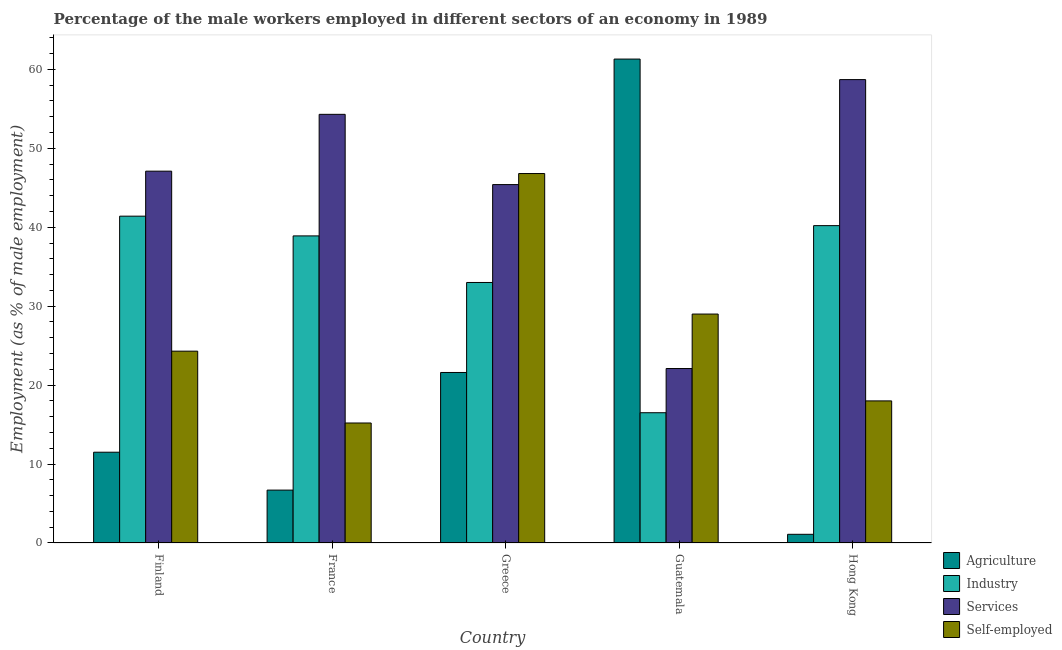How many different coloured bars are there?
Offer a terse response. 4. Are the number of bars per tick equal to the number of legend labels?
Provide a short and direct response. Yes. Are the number of bars on each tick of the X-axis equal?
Provide a short and direct response. Yes. How many bars are there on the 2nd tick from the left?
Give a very brief answer. 4. What is the label of the 4th group of bars from the left?
Give a very brief answer. Guatemala. What is the percentage of self employed male workers in Finland?
Keep it short and to the point. 24.3. Across all countries, what is the maximum percentage of male workers in industry?
Provide a short and direct response. 41.4. Across all countries, what is the minimum percentage of self employed male workers?
Make the answer very short. 15.2. In which country was the percentage of self employed male workers maximum?
Ensure brevity in your answer.  Greece. In which country was the percentage of male workers in agriculture minimum?
Give a very brief answer. Hong Kong. What is the total percentage of male workers in agriculture in the graph?
Make the answer very short. 102.2. What is the difference between the percentage of male workers in services in Greece and that in Hong Kong?
Your answer should be compact. -13.3. What is the difference between the percentage of male workers in services in Greece and the percentage of self employed male workers in France?
Make the answer very short. 30.2. What is the average percentage of self employed male workers per country?
Your answer should be very brief. 26.66. What is the difference between the percentage of male workers in agriculture and percentage of male workers in industry in Greece?
Offer a very short reply. -11.4. What is the ratio of the percentage of male workers in industry in Finland to that in Guatemala?
Ensure brevity in your answer.  2.51. Is the percentage of male workers in industry in Finland less than that in Greece?
Make the answer very short. No. What is the difference between the highest and the second highest percentage of self employed male workers?
Offer a very short reply. 17.8. What is the difference between the highest and the lowest percentage of self employed male workers?
Offer a very short reply. 31.6. What does the 1st bar from the left in Greece represents?
Ensure brevity in your answer.  Agriculture. What does the 4th bar from the right in Hong Kong represents?
Make the answer very short. Agriculture. How many countries are there in the graph?
Your response must be concise. 5. What is the difference between two consecutive major ticks on the Y-axis?
Your answer should be compact. 10. Are the values on the major ticks of Y-axis written in scientific E-notation?
Your answer should be very brief. No. Does the graph contain any zero values?
Offer a terse response. No. What is the title of the graph?
Your response must be concise. Percentage of the male workers employed in different sectors of an economy in 1989. Does "Argument" appear as one of the legend labels in the graph?
Your response must be concise. No. What is the label or title of the Y-axis?
Make the answer very short. Employment (as % of male employment). What is the Employment (as % of male employment) of Industry in Finland?
Ensure brevity in your answer.  41.4. What is the Employment (as % of male employment) of Services in Finland?
Provide a short and direct response. 47.1. What is the Employment (as % of male employment) of Self-employed in Finland?
Your response must be concise. 24.3. What is the Employment (as % of male employment) in Agriculture in France?
Offer a terse response. 6.7. What is the Employment (as % of male employment) of Industry in France?
Give a very brief answer. 38.9. What is the Employment (as % of male employment) in Services in France?
Offer a very short reply. 54.3. What is the Employment (as % of male employment) in Self-employed in France?
Ensure brevity in your answer.  15.2. What is the Employment (as % of male employment) of Agriculture in Greece?
Your answer should be very brief. 21.6. What is the Employment (as % of male employment) in Services in Greece?
Provide a succinct answer. 45.4. What is the Employment (as % of male employment) of Self-employed in Greece?
Give a very brief answer. 46.8. What is the Employment (as % of male employment) in Agriculture in Guatemala?
Offer a very short reply. 61.3. What is the Employment (as % of male employment) of Industry in Guatemala?
Offer a terse response. 16.5. What is the Employment (as % of male employment) of Services in Guatemala?
Give a very brief answer. 22.1. What is the Employment (as % of male employment) of Self-employed in Guatemala?
Provide a short and direct response. 29. What is the Employment (as % of male employment) in Agriculture in Hong Kong?
Your answer should be compact. 1.1. What is the Employment (as % of male employment) in Industry in Hong Kong?
Your answer should be compact. 40.2. What is the Employment (as % of male employment) in Services in Hong Kong?
Provide a succinct answer. 58.7. What is the Employment (as % of male employment) of Self-employed in Hong Kong?
Offer a terse response. 18. Across all countries, what is the maximum Employment (as % of male employment) in Agriculture?
Ensure brevity in your answer.  61.3. Across all countries, what is the maximum Employment (as % of male employment) of Industry?
Your answer should be compact. 41.4. Across all countries, what is the maximum Employment (as % of male employment) in Services?
Provide a short and direct response. 58.7. Across all countries, what is the maximum Employment (as % of male employment) of Self-employed?
Offer a terse response. 46.8. Across all countries, what is the minimum Employment (as % of male employment) in Agriculture?
Give a very brief answer. 1.1. Across all countries, what is the minimum Employment (as % of male employment) in Industry?
Your answer should be compact. 16.5. Across all countries, what is the minimum Employment (as % of male employment) in Services?
Give a very brief answer. 22.1. Across all countries, what is the minimum Employment (as % of male employment) in Self-employed?
Your answer should be compact. 15.2. What is the total Employment (as % of male employment) in Agriculture in the graph?
Your answer should be very brief. 102.2. What is the total Employment (as % of male employment) in Industry in the graph?
Make the answer very short. 170. What is the total Employment (as % of male employment) of Services in the graph?
Offer a very short reply. 227.6. What is the total Employment (as % of male employment) of Self-employed in the graph?
Keep it short and to the point. 133.3. What is the difference between the Employment (as % of male employment) of Industry in Finland and that in Greece?
Ensure brevity in your answer.  8.4. What is the difference between the Employment (as % of male employment) in Self-employed in Finland and that in Greece?
Provide a short and direct response. -22.5. What is the difference between the Employment (as % of male employment) in Agriculture in Finland and that in Guatemala?
Provide a succinct answer. -49.8. What is the difference between the Employment (as % of male employment) in Industry in Finland and that in Guatemala?
Make the answer very short. 24.9. What is the difference between the Employment (as % of male employment) of Self-employed in Finland and that in Guatemala?
Your answer should be compact. -4.7. What is the difference between the Employment (as % of male employment) in Agriculture in Finland and that in Hong Kong?
Provide a short and direct response. 10.4. What is the difference between the Employment (as % of male employment) of Self-employed in Finland and that in Hong Kong?
Your response must be concise. 6.3. What is the difference between the Employment (as % of male employment) in Agriculture in France and that in Greece?
Your answer should be very brief. -14.9. What is the difference between the Employment (as % of male employment) of Industry in France and that in Greece?
Your answer should be very brief. 5.9. What is the difference between the Employment (as % of male employment) in Self-employed in France and that in Greece?
Offer a terse response. -31.6. What is the difference between the Employment (as % of male employment) of Agriculture in France and that in Guatemala?
Ensure brevity in your answer.  -54.6. What is the difference between the Employment (as % of male employment) in Industry in France and that in Guatemala?
Provide a succinct answer. 22.4. What is the difference between the Employment (as % of male employment) in Services in France and that in Guatemala?
Ensure brevity in your answer.  32.2. What is the difference between the Employment (as % of male employment) in Services in France and that in Hong Kong?
Provide a succinct answer. -4.4. What is the difference between the Employment (as % of male employment) in Self-employed in France and that in Hong Kong?
Your response must be concise. -2.8. What is the difference between the Employment (as % of male employment) of Agriculture in Greece and that in Guatemala?
Provide a short and direct response. -39.7. What is the difference between the Employment (as % of male employment) in Services in Greece and that in Guatemala?
Give a very brief answer. 23.3. What is the difference between the Employment (as % of male employment) of Agriculture in Greece and that in Hong Kong?
Provide a succinct answer. 20.5. What is the difference between the Employment (as % of male employment) of Services in Greece and that in Hong Kong?
Provide a succinct answer. -13.3. What is the difference between the Employment (as % of male employment) of Self-employed in Greece and that in Hong Kong?
Offer a terse response. 28.8. What is the difference between the Employment (as % of male employment) in Agriculture in Guatemala and that in Hong Kong?
Make the answer very short. 60.2. What is the difference between the Employment (as % of male employment) in Industry in Guatemala and that in Hong Kong?
Offer a terse response. -23.7. What is the difference between the Employment (as % of male employment) of Services in Guatemala and that in Hong Kong?
Give a very brief answer. -36.6. What is the difference between the Employment (as % of male employment) of Self-employed in Guatemala and that in Hong Kong?
Provide a succinct answer. 11. What is the difference between the Employment (as % of male employment) in Agriculture in Finland and the Employment (as % of male employment) in Industry in France?
Your response must be concise. -27.4. What is the difference between the Employment (as % of male employment) of Agriculture in Finland and the Employment (as % of male employment) of Services in France?
Keep it short and to the point. -42.8. What is the difference between the Employment (as % of male employment) of Industry in Finland and the Employment (as % of male employment) of Services in France?
Your answer should be very brief. -12.9. What is the difference between the Employment (as % of male employment) in Industry in Finland and the Employment (as % of male employment) in Self-employed in France?
Your response must be concise. 26.2. What is the difference between the Employment (as % of male employment) in Services in Finland and the Employment (as % of male employment) in Self-employed in France?
Your answer should be very brief. 31.9. What is the difference between the Employment (as % of male employment) of Agriculture in Finland and the Employment (as % of male employment) of Industry in Greece?
Offer a terse response. -21.5. What is the difference between the Employment (as % of male employment) in Agriculture in Finland and the Employment (as % of male employment) in Services in Greece?
Provide a short and direct response. -33.9. What is the difference between the Employment (as % of male employment) of Agriculture in Finland and the Employment (as % of male employment) of Self-employed in Greece?
Offer a terse response. -35.3. What is the difference between the Employment (as % of male employment) in Industry in Finland and the Employment (as % of male employment) in Services in Greece?
Your response must be concise. -4. What is the difference between the Employment (as % of male employment) of Industry in Finland and the Employment (as % of male employment) of Self-employed in Greece?
Provide a short and direct response. -5.4. What is the difference between the Employment (as % of male employment) in Services in Finland and the Employment (as % of male employment) in Self-employed in Greece?
Keep it short and to the point. 0.3. What is the difference between the Employment (as % of male employment) in Agriculture in Finland and the Employment (as % of male employment) in Self-employed in Guatemala?
Provide a short and direct response. -17.5. What is the difference between the Employment (as % of male employment) of Industry in Finland and the Employment (as % of male employment) of Services in Guatemala?
Keep it short and to the point. 19.3. What is the difference between the Employment (as % of male employment) in Services in Finland and the Employment (as % of male employment) in Self-employed in Guatemala?
Offer a terse response. 18.1. What is the difference between the Employment (as % of male employment) in Agriculture in Finland and the Employment (as % of male employment) in Industry in Hong Kong?
Provide a succinct answer. -28.7. What is the difference between the Employment (as % of male employment) in Agriculture in Finland and the Employment (as % of male employment) in Services in Hong Kong?
Offer a very short reply. -47.2. What is the difference between the Employment (as % of male employment) in Agriculture in Finland and the Employment (as % of male employment) in Self-employed in Hong Kong?
Your answer should be compact. -6.5. What is the difference between the Employment (as % of male employment) of Industry in Finland and the Employment (as % of male employment) of Services in Hong Kong?
Make the answer very short. -17.3. What is the difference between the Employment (as % of male employment) in Industry in Finland and the Employment (as % of male employment) in Self-employed in Hong Kong?
Keep it short and to the point. 23.4. What is the difference between the Employment (as % of male employment) in Services in Finland and the Employment (as % of male employment) in Self-employed in Hong Kong?
Give a very brief answer. 29.1. What is the difference between the Employment (as % of male employment) in Agriculture in France and the Employment (as % of male employment) in Industry in Greece?
Offer a terse response. -26.3. What is the difference between the Employment (as % of male employment) in Agriculture in France and the Employment (as % of male employment) in Services in Greece?
Make the answer very short. -38.7. What is the difference between the Employment (as % of male employment) of Agriculture in France and the Employment (as % of male employment) of Self-employed in Greece?
Keep it short and to the point. -40.1. What is the difference between the Employment (as % of male employment) of Industry in France and the Employment (as % of male employment) of Self-employed in Greece?
Provide a succinct answer. -7.9. What is the difference between the Employment (as % of male employment) of Services in France and the Employment (as % of male employment) of Self-employed in Greece?
Your answer should be very brief. 7.5. What is the difference between the Employment (as % of male employment) of Agriculture in France and the Employment (as % of male employment) of Industry in Guatemala?
Give a very brief answer. -9.8. What is the difference between the Employment (as % of male employment) in Agriculture in France and the Employment (as % of male employment) in Services in Guatemala?
Your answer should be compact. -15.4. What is the difference between the Employment (as % of male employment) of Agriculture in France and the Employment (as % of male employment) of Self-employed in Guatemala?
Offer a very short reply. -22.3. What is the difference between the Employment (as % of male employment) of Industry in France and the Employment (as % of male employment) of Services in Guatemala?
Your response must be concise. 16.8. What is the difference between the Employment (as % of male employment) of Industry in France and the Employment (as % of male employment) of Self-employed in Guatemala?
Offer a very short reply. 9.9. What is the difference between the Employment (as % of male employment) in Services in France and the Employment (as % of male employment) in Self-employed in Guatemala?
Provide a succinct answer. 25.3. What is the difference between the Employment (as % of male employment) in Agriculture in France and the Employment (as % of male employment) in Industry in Hong Kong?
Provide a succinct answer. -33.5. What is the difference between the Employment (as % of male employment) of Agriculture in France and the Employment (as % of male employment) of Services in Hong Kong?
Ensure brevity in your answer.  -52. What is the difference between the Employment (as % of male employment) in Industry in France and the Employment (as % of male employment) in Services in Hong Kong?
Ensure brevity in your answer.  -19.8. What is the difference between the Employment (as % of male employment) in Industry in France and the Employment (as % of male employment) in Self-employed in Hong Kong?
Make the answer very short. 20.9. What is the difference between the Employment (as % of male employment) in Services in France and the Employment (as % of male employment) in Self-employed in Hong Kong?
Make the answer very short. 36.3. What is the difference between the Employment (as % of male employment) of Agriculture in Greece and the Employment (as % of male employment) of Services in Guatemala?
Provide a succinct answer. -0.5. What is the difference between the Employment (as % of male employment) in Agriculture in Greece and the Employment (as % of male employment) in Self-employed in Guatemala?
Your answer should be very brief. -7.4. What is the difference between the Employment (as % of male employment) in Industry in Greece and the Employment (as % of male employment) in Services in Guatemala?
Offer a terse response. 10.9. What is the difference between the Employment (as % of male employment) in Agriculture in Greece and the Employment (as % of male employment) in Industry in Hong Kong?
Provide a short and direct response. -18.6. What is the difference between the Employment (as % of male employment) of Agriculture in Greece and the Employment (as % of male employment) of Services in Hong Kong?
Make the answer very short. -37.1. What is the difference between the Employment (as % of male employment) in Agriculture in Greece and the Employment (as % of male employment) in Self-employed in Hong Kong?
Provide a succinct answer. 3.6. What is the difference between the Employment (as % of male employment) in Industry in Greece and the Employment (as % of male employment) in Services in Hong Kong?
Your response must be concise. -25.7. What is the difference between the Employment (as % of male employment) of Industry in Greece and the Employment (as % of male employment) of Self-employed in Hong Kong?
Make the answer very short. 15. What is the difference between the Employment (as % of male employment) of Services in Greece and the Employment (as % of male employment) of Self-employed in Hong Kong?
Your response must be concise. 27.4. What is the difference between the Employment (as % of male employment) in Agriculture in Guatemala and the Employment (as % of male employment) in Industry in Hong Kong?
Your answer should be very brief. 21.1. What is the difference between the Employment (as % of male employment) in Agriculture in Guatemala and the Employment (as % of male employment) in Self-employed in Hong Kong?
Offer a terse response. 43.3. What is the difference between the Employment (as % of male employment) of Industry in Guatemala and the Employment (as % of male employment) of Services in Hong Kong?
Provide a succinct answer. -42.2. What is the average Employment (as % of male employment) of Agriculture per country?
Offer a very short reply. 20.44. What is the average Employment (as % of male employment) of Industry per country?
Offer a terse response. 34. What is the average Employment (as % of male employment) of Services per country?
Ensure brevity in your answer.  45.52. What is the average Employment (as % of male employment) in Self-employed per country?
Keep it short and to the point. 26.66. What is the difference between the Employment (as % of male employment) in Agriculture and Employment (as % of male employment) in Industry in Finland?
Keep it short and to the point. -29.9. What is the difference between the Employment (as % of male employment) of Agriculture and Employment (as % of male employment) of Services in Finland?
Provide a short and direct response. -35.6. What is the difference between the Employment (as % of male employment) of Agriculture and Employment (as % of male employment) of Self-employed in Finland?
Your answer should be very brief. -12.8. What is the difference between the Employment (as % of male employment) in Industry and Employment (as % of male employment) in Services in Finland?
Offer a very short reply. -5.7. What is the difference between the Employment (as % of male employment) in Industry and Employment (as % of male employment) in Self-employed in Finland?
Make the answer very short. 17.1. What is the difference between the Employment (as % of male employment) in Services and Employment (as % of male employment) in Self-employed in Finland?
Your response must be concise. 22.8. What is the difference between the Employment (as % of male employment) in Agriculture and Employment (as % of male employment) in Industry in France?
Offer a very short reply. -32.2. What is the difference between the Employment (as % of male employment) of Agriculture and Employment (as % of male employment) of Services in France?
Your response must be concise. -47.6. What is the difference between the Employment (as % of male employment) in Agriculture and Employment (as % of male employment) in Self-employed in France?
Offer a very short reply. -8.5. What is the difference between the Employment (as % of male employment) of Industry and Employment (as % of male employment) of Services in France?
Keep it short and to the point. -15.4. What is the difference between the Employment (as % of male employment) of Industry and Employment (as % of male employment) of Self-employed in France?
Ensure brevity in your answer.  23.7. What is the difference between the Employment (as % of male employment) of Services and Employment (as % of male employment) of Self-employed in France?
Your answer should be very brief. 39.1. What is the difference between the Employment (as % of male employment) of Agriculture and Employment (as % of male employment) of Services in Greece?
Provide a succinct answer. -23.8. What is the difference between the Employment (as % of male employment) of Agriculture and Employment (as % of male employment) of Self-employed in Greece?
Offer a terse response. -25.2. What is the difference between the Employment (as % of male employment) in Industry and Employment (as % of male employment) in Services in Greece?
Provide a succinct answer. -12.4. What is the difference between the Employment (as % of male employment) in Services and Employment (as % of male employment) in Self-employed in Greece?
Offer a very short reply. -1.4. What is the difference between the Employment (as % of male employment) in Agriculture and Employment (as % of male employment) in Industry in Guatemala?
Make the answer very short. 44.8. What is the difference between the Employment (as % of male employment) of Agriculture and Employment (as % of male employment) of Services in Guatemala?
Offer a terse response. 39.2. What is the difference between the Employment (as % of male employment) of Agriculture and Employment (as % of male employment) of Self-employed in Guatemala?
Your answer should be compact. 32.3. What is the difference between the Employment (as % of male employment) of Industry and Employment (as % of male employment) of Self-employed in Guatemala?
Provide a succinct answer. -12.5. What is the difference between the Employment (as % of male employment) in Agriculture and Employment (as % of male employment) in Industry in Hong Kong?
Give a very brief answer. -39.1. What is the difference between the Employment (as % of male employment) of Agriculture and Employment (as % of male employment) of Services in Hong Kong?
Your answer should be very brief. -57.6. What is the difference between the Employment (as % of male employment) in Agriculture and Employment (as % of male employment) in Self-employed in Hong Kong?
Give a very brief answer. -16.9. What is the difference between the Employment (as % of male employment) in Industry and Employment (as % of male employment) in Services in Hong Kong?
Give a very brief answer. -18.5. What is the difference between the Employment (as % of male employment) of Services and Employment (as % of male employment) of Self-employed in Hong Kong?
Your answer should be compact. 40.7. What is the ratio of the Employment (as % of male employment) in Agriculture in Finland to that in France?
Make the answer very short. 1.72. What is the ratio of the Employment (as % of male employment) of Industry in Finland to that in France?
Offer a very short reply. 1.06. What is the ratio of the Employment (as % of male employment) in Services in Finland to that in France?
Offer a very short reply. 0.87. What is the ratio of the Employment (as % of male employment) in Self-employed in Finland to that in France?
Give a very brief answer. 1.6. What is the ratio of the Employment (as % of male employment) in Agriculture in Finland to that in Greece?
Offer a terse response. 0.53. What is the ratio of the Employment (as % of male employment) in Industry in Finland to that in Greece?
Provide a short and direct response. 1.25. What is the ratio of the Employment (as % of male employment) in Services in Finland to that in Greece?
Your answer should be compact. 1.04. What is the ratio of the Employment (as % of male employment) in Self-employed in Finland to that in Greece?
Give a very brief answer. 0.52. What is the ratio of the Employment (as % of male employment) in Agriculture in Finland to that in Guatemala?
Make the answer very short. 0.19. What is the ratio of the Employment (as % of male employment) in Industry in Finland to that in Guatemala?
Provide a short and direct response. 2.51. What is the ratio of the Employment (as % of male employment) in Services in Finland to that in Guatemala?
Provide a short and direct response. 2.13. What is the ratio of the Employment (as % of male employment) of Self-employed in Finland to that in Guatemala?
Give a very brief answer. 0.84. What is the ratio of the Employment (as % of male employment) in Agriculture in Finland to that in Hong Kong?
Offer a terse response. 10.45. What is the ratio of the Employment (as % of male employment) in Industry in Finland to that in Hong Kong?
Your answer should be very brief. 1.03. What is the ratio of the Employment (as % of male employment) in Services in Finland to that in Hong Kong?
Make the answer very short. 0.8. What is the ratio of the Employment (as % of male employment) of Self-employed in Finland to that in Hong Kong?
Make the answer very short. 1.35. What is the ratio of the Employment (as % of male employment) of Agriculture in France to that in Greece?
Provide a succinct answer. 0.31. What is the ratio of the Employment (as % of male employment) in Industry in France to that in Greece?
Make the answer very short. 1.18. What is the ratio of the Employment (as % of male employment) in Services in France to that in Greece?
Your answer should be compact. 1.2. What is the ratio of the Employment (as % of male employment) in Self-employed in France to that in Greece?
Your response must be concise. 0.32. What is the ratio of the Employment (as % of male employment) in Agriculture in France to that in Guatemala?
Offer a very short reply. 0.11. What is the ratio of the Employment (as % of male employment) of Industry in France to that in Guatemala?
Make the answer very short. 2.36. What is the ratio of the Employment (as % of male employment) of Services in France to that in Guatemala?
Give a very brief answer. 2.46. What is the ratio of the Employment (as % of male employment) in Self-employed in France to that in Guatemala?
Provide a succinct answer. 0.52. What is the ratio of the Employment (as % of male employment) in Agriculture in France to that in Hong Kong?
Keep it short and to the point. 6.09. What is the ratio of the Employment (as % of male employment) of Services in France to that in Hong Kong?
Your response must be concise. 0.93. What is the ratio of the Employment (as % of male employment) of Self-employed in France to that in Hong Kong?
Make the answer very short. 0.84. What is the ratio of the Employment (as % of male employment) of Agriculture in Greece to that in Guatemala?
Your answer should be compact. 0.35. What is the ratio of the Employment (as % of male employment) in Industry in Greece to that in Guatemala?
Make the answer very short. 2. What is the ratio of the Employment (as % of male employment) in Services in Greece to that in Guatemala?
Your answer should be very brief. 2.05. What is the ratio of the Employment (as % of male employment) of Self-employed in Greece to that in Guatemala?
Keep it short and to the point. 1.61. What is the ratio of the Employment (as % of male employment) of Agriculture in Greece to that in Hong Kong?
Keep it short and to the point. 19.64. What is the ratio of the Employment (as % of male employment) in Industry in Greece to that in Hong Kong?
Provide a succinct answer. 0.82. What is the ratio of the Employment (as % of male employment) of Services in Greece to that in Hong Kong?
Ensure brevity in your answer.  0.77. What is the ratio of the Employment (as % of male employment) in Self-employed in Greece to that in Hong Kong?
Offer a very short reply. 2.6. What is the ratio of the Employment (as % of male employment) in Agriculture in Guatemala to that in Hong Kong?
Offer a terse response. 55.73. What is the ratio of the Employment (as % of male employment) of Industry in Guatemala to that in Hong Kong?
Offer a terse response. 0.41. What is the ratio of the Employment (as % of male employment) of Services in Guatemala to that in Hong Kong?
Your response must be concise. 0.38. What is the ratio of the Employment (as % of male employment) in Self-employed in Guatemala to that in Hong Kong?
Offer a very short reply. 1.61. What is the difference between the highest and the second highest Employment (as % of male employment) of Agriculture?
Provide a short and direct response. 39.7. What is the difference between the highest and the second highest Employment (as % of male employment) of Industry?
Give a very brief answer. 1.2. What is the difference between the highest and the second highest Employment (as % of male employment) of Services?
Give a very brief answer. 4.4. What is the difference between the highest and the second highest Employment (as % of male employment) in Self-employed?
Your answer should be very brief. 17.8. What is the difference between the highest and the lowest Employment (as % of male employment) of Agriculture?
Keep it short and to the point. 60.2. What is the difference between the highest and the lowest Employment (as % of male employment) of Industry?
Offer a very short reply. 24.9. What is the difference between the highest and the lowest Employment (as % of male employment) in Services?
Your answer should be very brief. 36.6. What is the difference between the highest and the lowest Employment (as % of male employment) of Self-employed?
Provide a short and direct response. 31.6. 